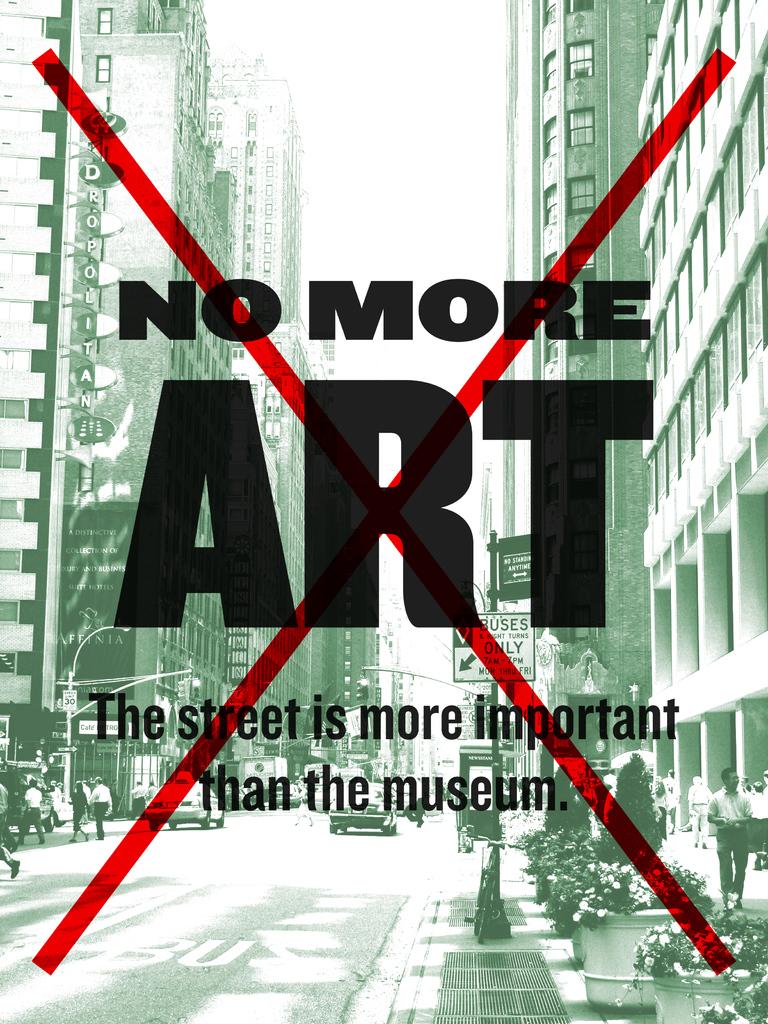Is this ad saying no to art?
Provide a succinct answer. Yes. What is this ad saying the street is more important than?
Provide a succinct answer. Museum. 